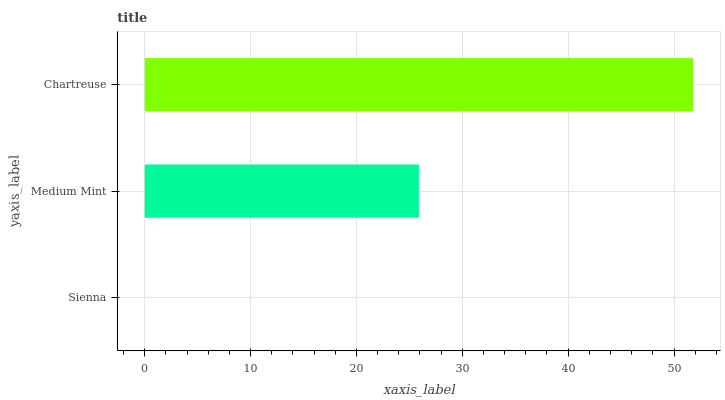Is Sienna the minimum?
Answer yes or no. Yes. Is Chartreuse the maximum?
Answer yes or no. Yes. Is Medium Mint the minimum?
Answer yes or no. No. Is Medium Mint the maximum?
Answer yes or no. No. Is Medium Mint greater than Sienna?
Answer yes or no. Yes. Is Sienna less than Medium Mint?
Answer yes or no. Yes. Is Sienna greater than Medium Mint?
Answer yes or no. No. Is Medium Mint less than Sienna?
Answer yes or no. No. Is Medium Mint the high median?
Answer yes or no. Yes. Is Medium Mint the low median?
Answer yes or no. Yes. Is Chartreuse the high median?
Answer yes or no. No. Is Sienna the low median?
Answer yes or no. No. 